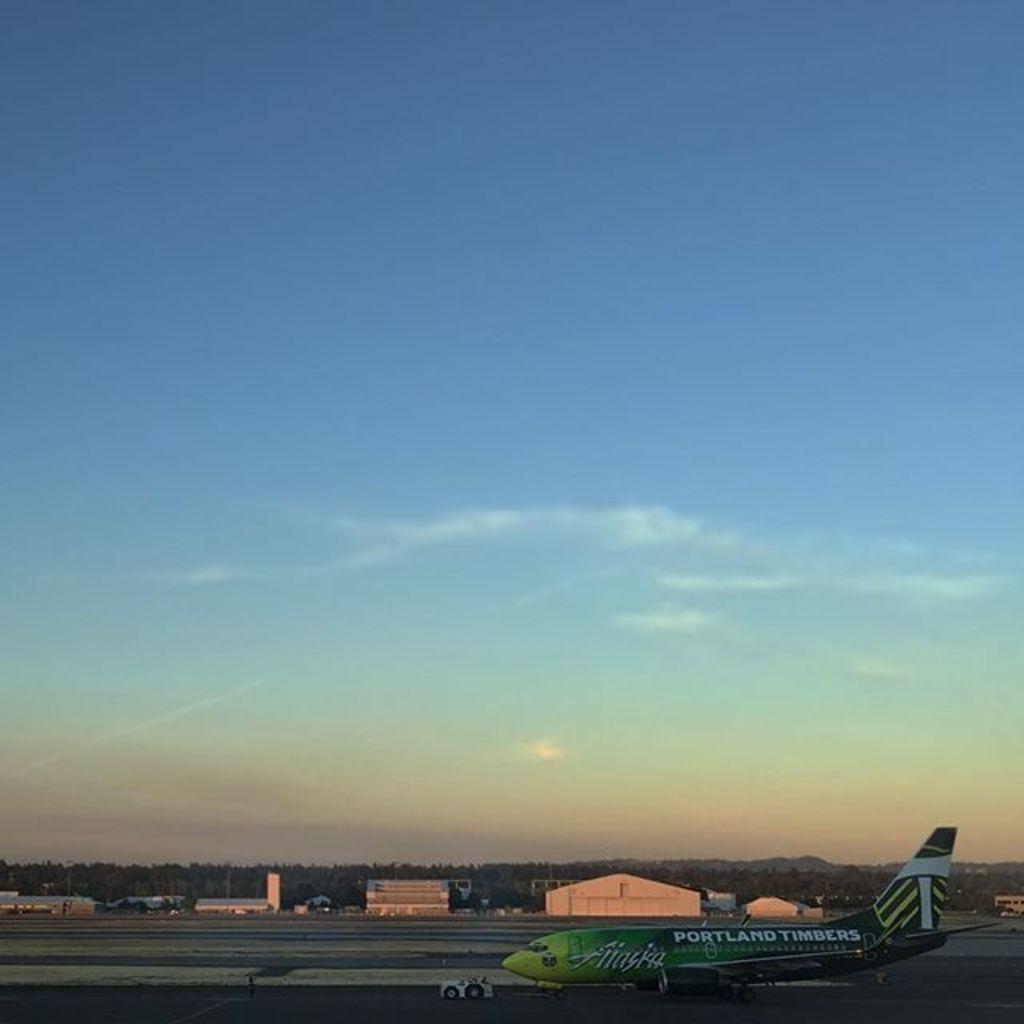In one or two sentences, can you explain what this image depicts? In the picture we can see a run way on it we can see a plane which is green in color with some advertisements on it and behind it we can see some buildings, shed and behind it we can see full of trees, hills and sky with clouds. 